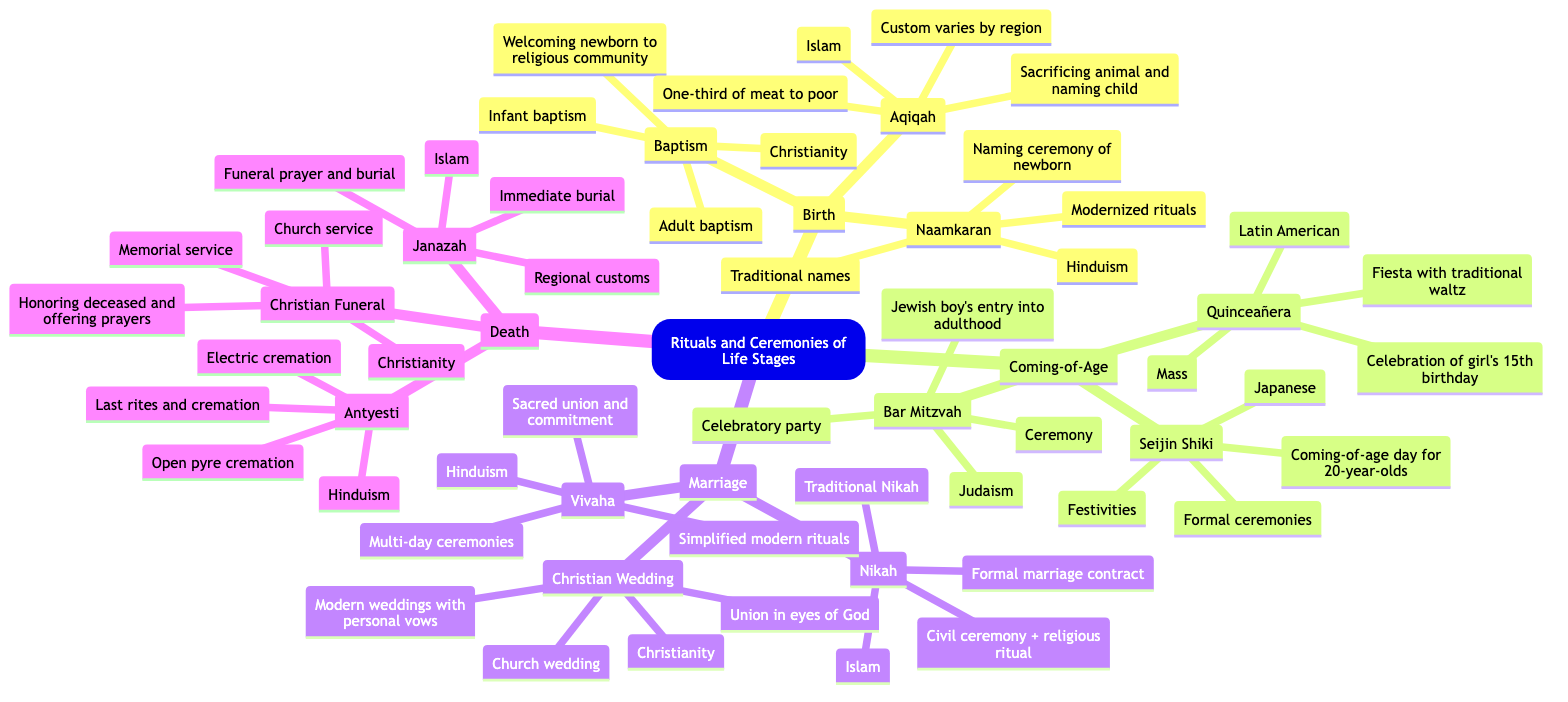What is the significance of Baptism? Baptism is significant as it welcomes the newborn into the religious community of Christianity. This is directly mentioned in the diagram under the Baptism node.
Answer: Welcoming the newborn into the religious community How many ceremonies are listed under Coming-of-Age? In the diagram, there are three ceremonies listed under Coming-of-Age: Bar Mitzvah, Quinceañera, and Seijin Shiki, which can be counted from the nodes.
Answer: 3 What cultures practice Aqiqah? The Aqiqah ceremony is practiced in Islam, which is indicated under the Aqiqah node in the diagram.
Answer: Islam What is a common variation of Christian weddings? A common variation of Christian weddings is that they can be modern weddings with personal vows. This is specified in the Marriage section of the diagram.
Answer: Modern weddings with personal vows How does the significance of Antyesti compare to Christian Funeral? Antyesti is significant for last rites and cremation in Hinduism, while Christian Funeral focuses on honoring the deceased and offering prayers. Both significance statements can be found under their respective nodes.
Answer: Last rites and cremation vs. Honoring the deceased Which ceremony marks a girl's 15th birthday? The ceremony that marks a girl's 15th birthday is Quinceañera, as stated in the Coming-of-Age section of the diagram.
Answer: Quinceañera What are the two variations of Naamkaran mentioned? The two variations of Naamkaran are traditional names and modernized rituals, which can be found listed under the Naamkaran node in the diagram.
Answer: Traditional names, Modernized rituals Which life stage has a ceremony called Nikah? The life stage that has a ceremony called Nikah is Marriage, as specified in the Marriage section of the mind map.
Answer: Marriage What is the main action performed during Aqiqah? The main action performed during Aqiqah is sacrificing an animal and naming the child, which is highlighted under the Aqiqah node.
Answer: Sacrificing an animal and naming the child 